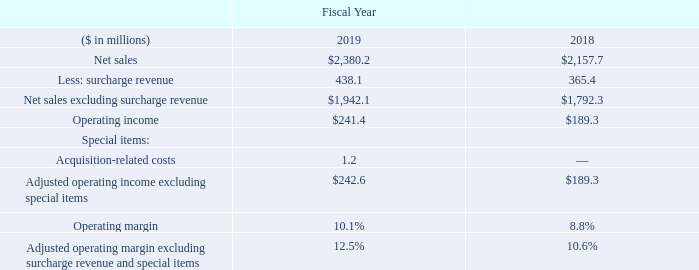Operating Income
Our operating income in fiscal year 2019 increased to $241.4 million, or 10.1 percent of net sales as compared with $189.3 million, or 8.8 percent of net sales in fiscal year 2018. Excluding surcharge revenue and special items, adjusted operating margin was 12.5 percent for the fiscal year 2019 and 10.6 percent for the same period a year ago. The increase in the operating margin reflects steady demand and improved product mix coupled with operating cost improvements offset by higher selling, general and administrative expenses compared to the same period a year ago.
The following presents our operating income and operating margin, in each case excluding the impact of surcharge on net sales and special items. We present and discuss these financial measures because management believes removing the impact of these items provides a more consistent and meaningful basis for comparing results of operations from period to period. See the section “Non-GAAP Financial Measures” below for further discussion of these financial measures.
What was the amount of operating income in 2019? $241.4 million. What was the amount of operating income as percentage of net sales in 2018? 8.8 percent. In which years was operating income calculated? 2019, 2018. In which year was the operating margin larger? 10.1%>8.8%
Answer: 2019. What was the change in the amount of surcharge revenue from 2018 to 2019?
Answer scale should be: million. 438.1-365.4
Answer: 72.7. What was the percentage change in the amount of surcharge revenue from 2018 to 2019?
Answer scale should be: percent. (438.1-365.4)/365.4
Answer: 19.9. 